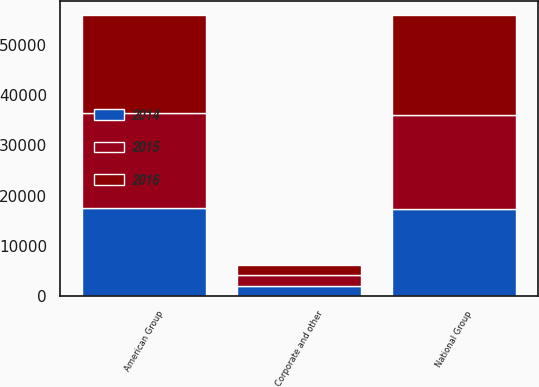<chart> <loc_0><loc_0><loc_500><loc_500><stacked_bar_chart><ecel><fcel>National Group<fcel>American Group<fcel>Corporate and other<nl><fcel>2016<fcel>19845<fcel>19648<fcel>1997<nl><fcel>2015<fcel>18756<fcel>18872<fcel>2050<nl><fcel>2014<fcel>17335<fcel>17532<fcel>2051<nl></chart> 